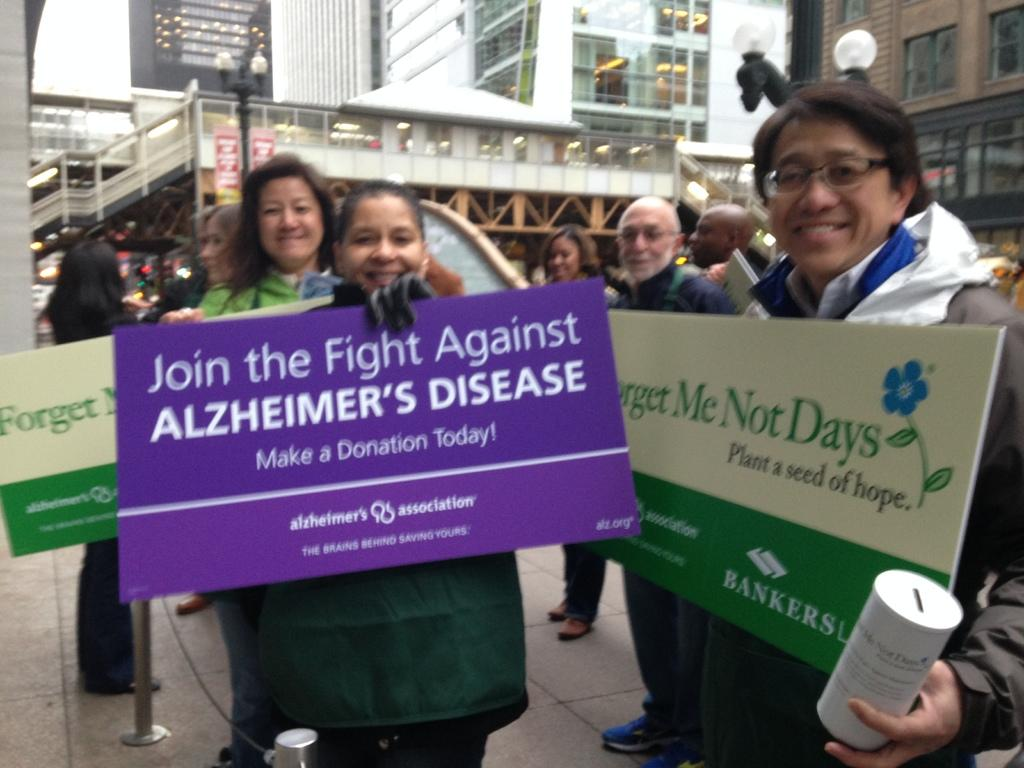What are the people in the image doing? The people in the image are standing and holding boards in their hands. What can be seen in the background of the image? There are buildings in the background of the image. What type of fuel is being used by the people in the image? There is no indication of any fuel being used in the image; the people are simply holding boards. 